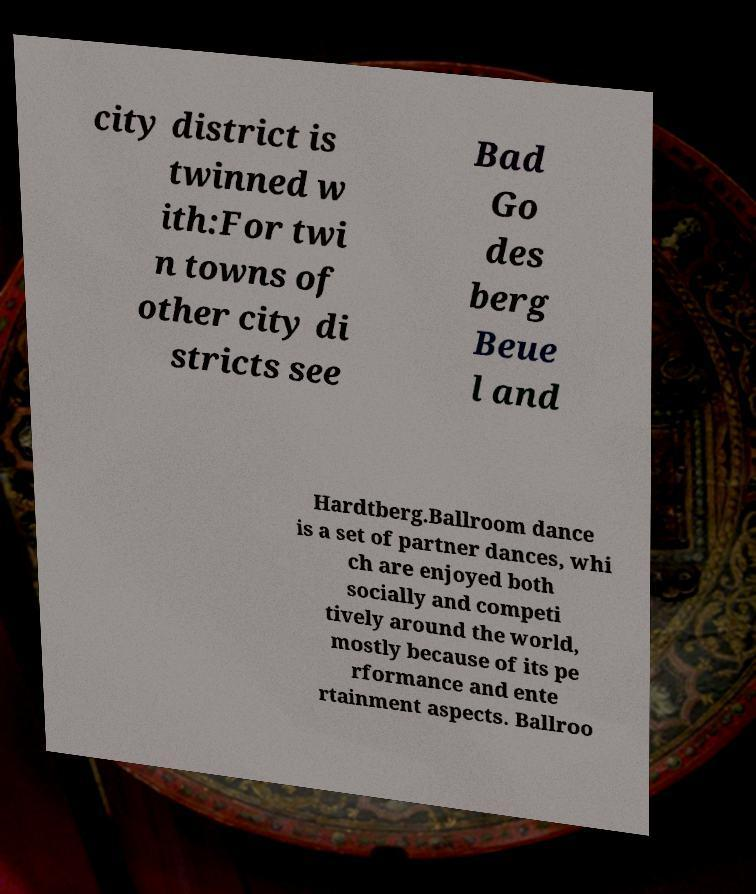Could you extract and type out the text from this image? city district is twinned w ith:For twi n towns of other city di stricts see Bad Go des berg Beue l and Hardtberg.Ballroom dance is a set of partner dances, whi ch are enjoyed both socially and competi tively around the world, mostly because of its pe rformance and ente rtainment aspects. Ballroo 